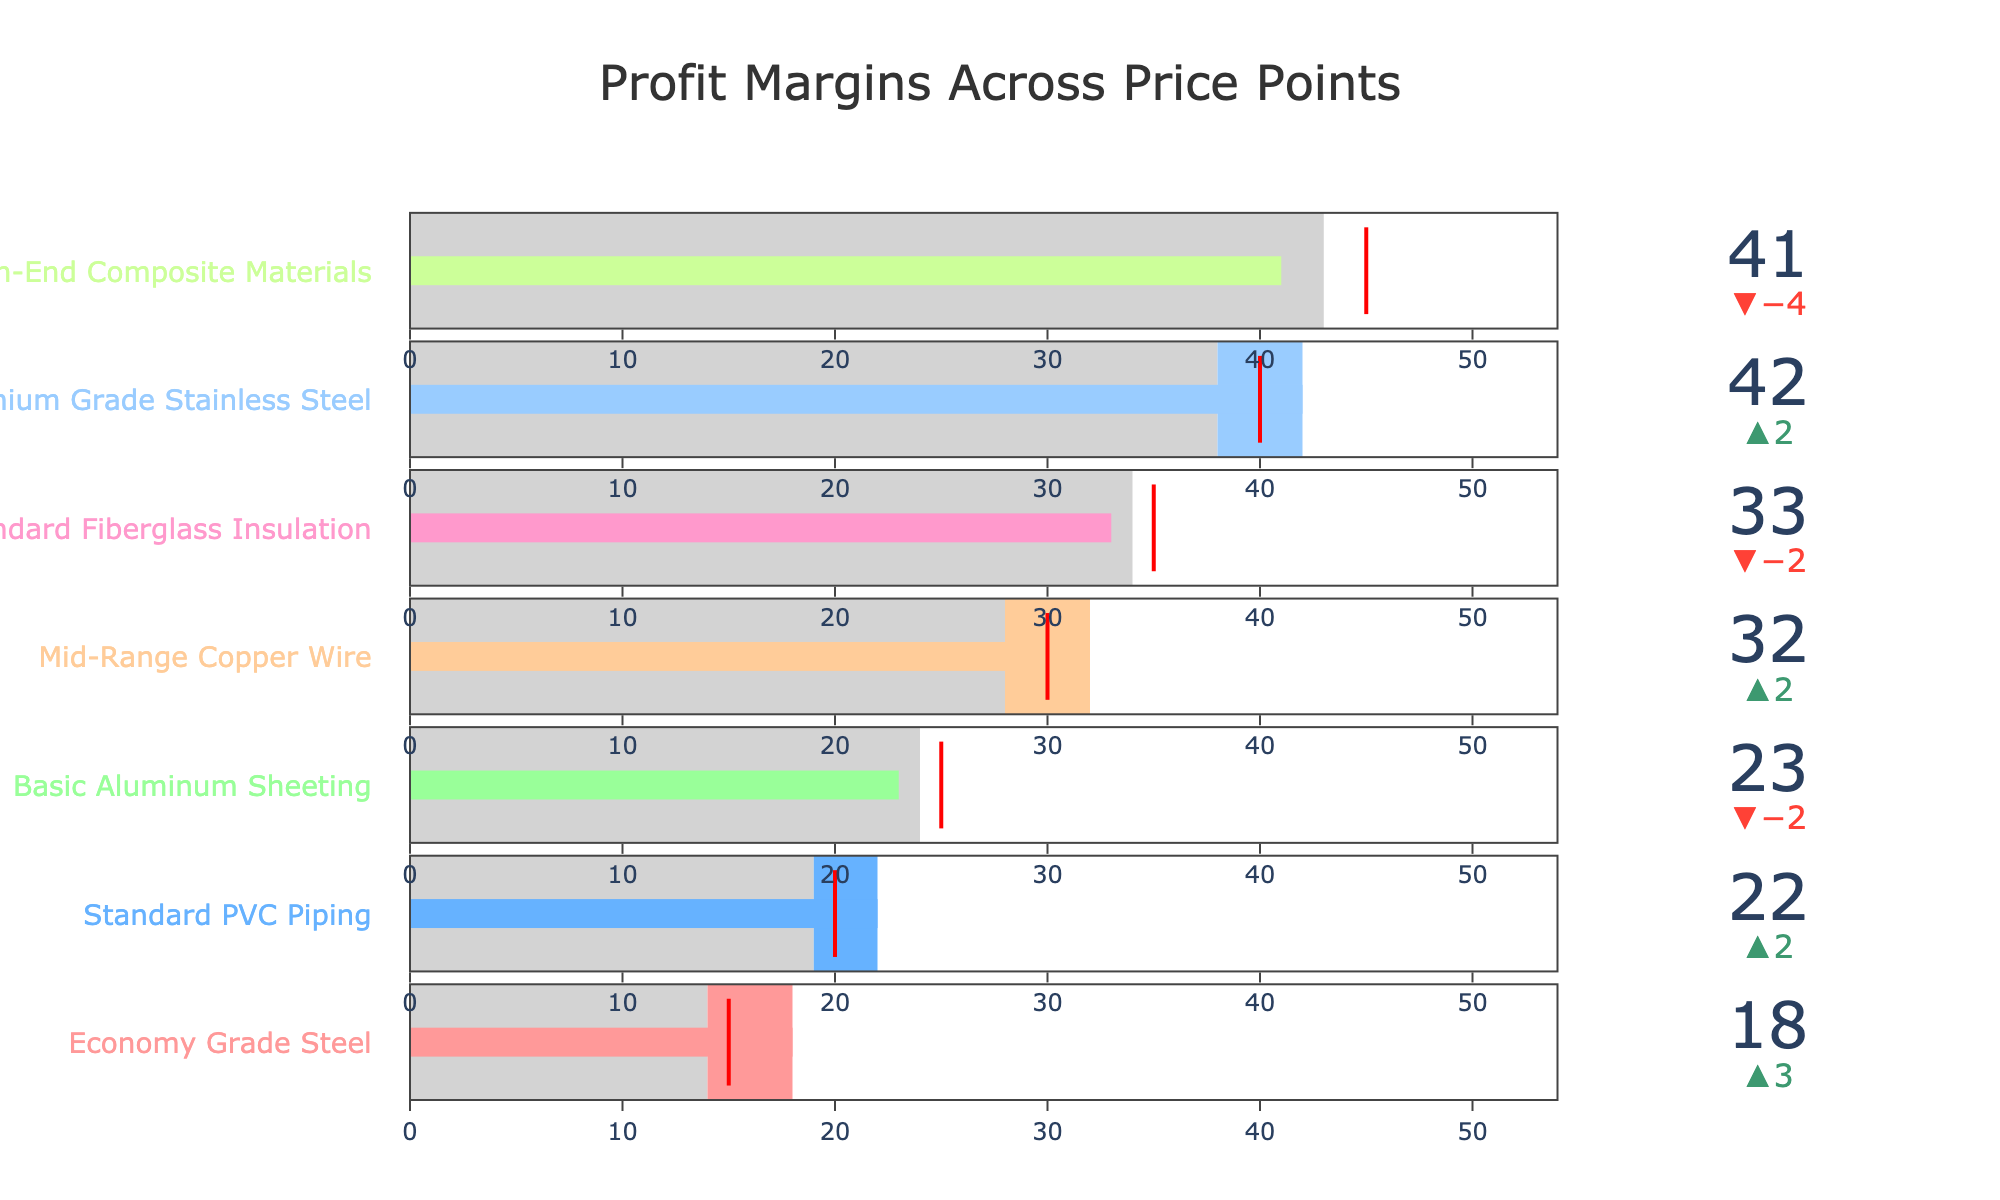How many different materials are displayed in the chart? Count the number of distinct bullet sections; each material is labeled. There are 7 materials in total.
Answer: 7 Which material has the highest actual profit margin? Look for the bullet section with the highest value on the gauge. Premium Grade Stainless Steel has the highest actual profit margin at 42.
Answer: Premium Grade Stainless Steel Is the actual profit margin of Standard PVC Piping higher than its target profit margin? Compare the actual profit margin (22) of Standard PVC Piping with its target profit margin (20). The actual profit margin is indeed higher.
Answer: Yes What is the color of the bar representing Premium Grade Stainless Steel? Identify the color used for the Premium Grade Stainless Steel bar, which is primarily pink.
Answer: Pink Which material has the lowest competitor average profit margin? Compare the competitor average margins visible in the chart. Economy Grade Steel has the lowest competitor average at 14.
Answer: Economy Grade Steel By how much does the actual profit margin of Mid-Range Copper Wire exceed the target profit margin? Subtract the target profit margin (30) from the actual profit margin (32) for Mid-Range Copper Wire. The difference is 2%.
Answer: 2% Which material's actual profit margin is closest to the competitor average? Compare the actual profit margins to competitor averages for each material, and Basic Aluminum Sheeting (23 vs. 24) is the closest.
Answer: Basic Aluminum Sheeting Is the profit margin for High-End Composite Materials above or below the competitor average? Compare the actual profit margin (41) with the competitor average (43) for High-End Composite Materials. The actual profit margin is below the competitor average. Above
Answer: Below Which materials have an actual profit margin that is at least 2% higher than their target profit margins? Identify materials where the difference between actual and target profit margins is 2 or more. Standard PVC Piping and Premium Grade Stainless Steel meet this criterion.
Answer: Standard PVC Piping, Premium Grade Stainless Steel 